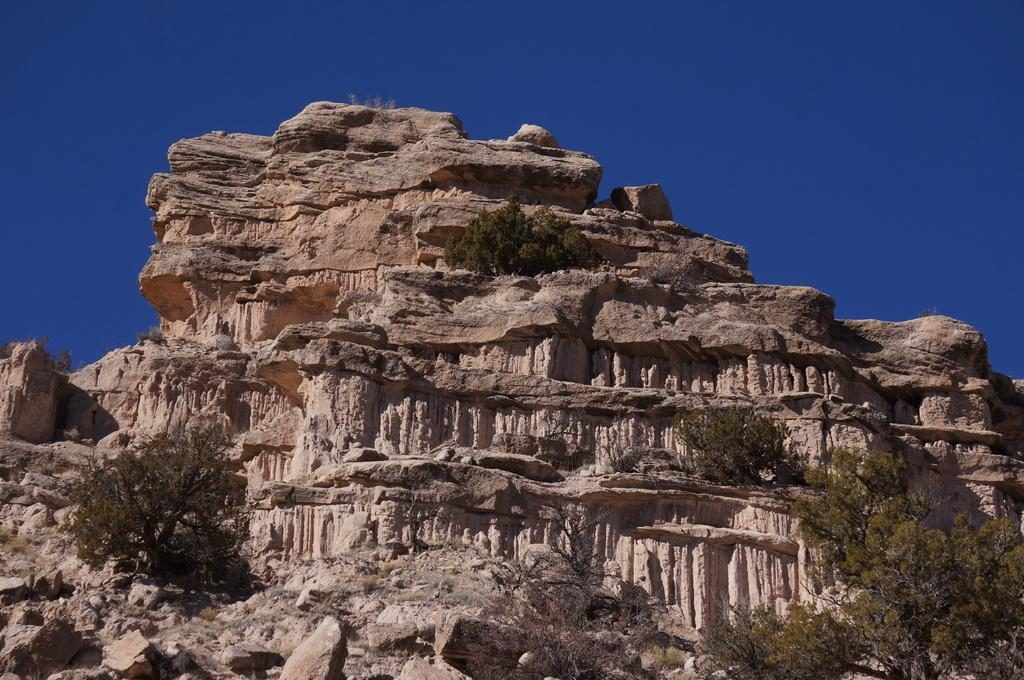What type of geological formation can be seen in the image? There is a rock mountain in the image. What type of vegetation is present in the image? Trees are present in the image. What can be seen in the background of the image? The sky is visible in the background of the image. What type of weather can be seen in the image? The provided facts do not mention any specific weather conditions, so we cannot determine the weather from the image. 